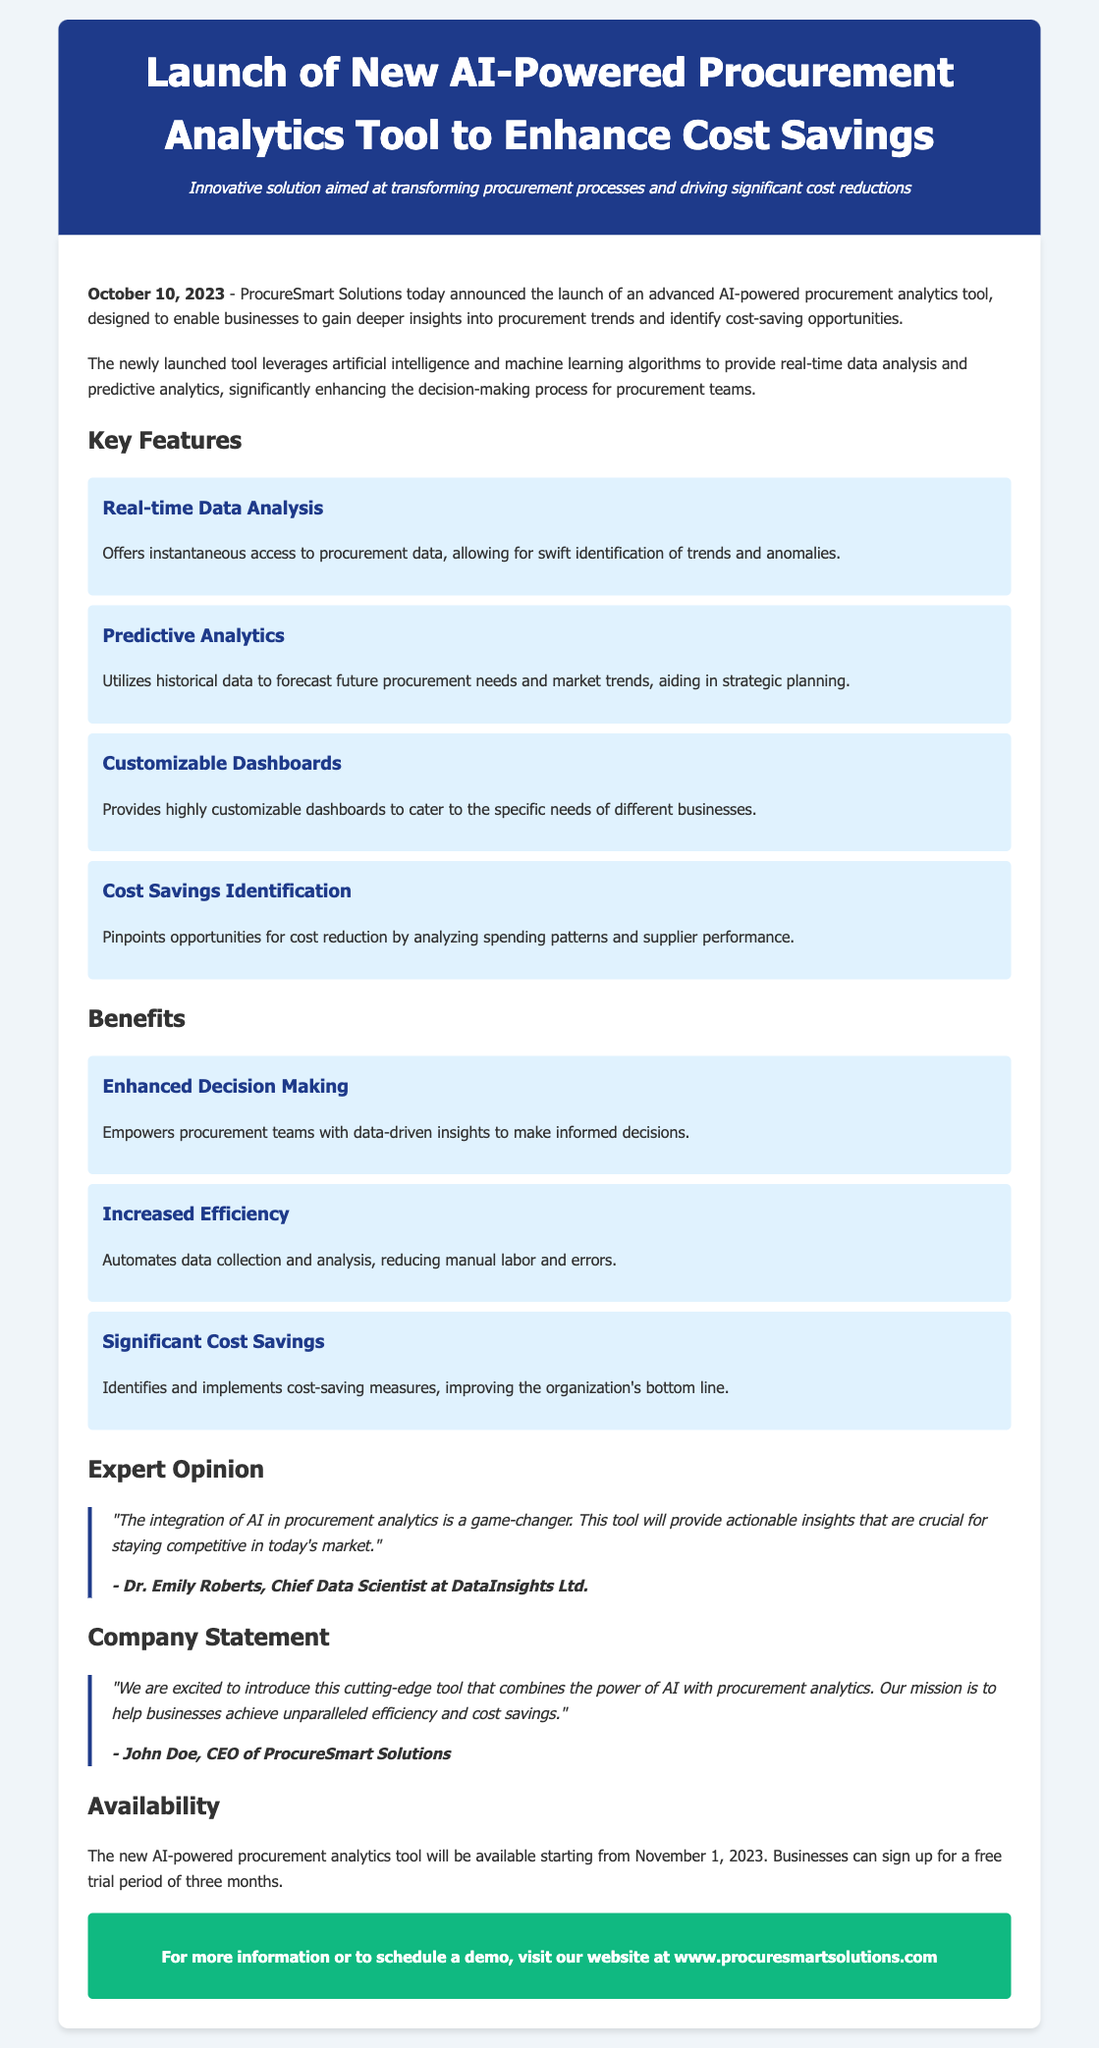What is the launch date of the new tool? The launch date mentioned in the document is October 10, 2023.
Answer: October 10, 2023 What is the name of the CEO of ProcureSmart Solutions? The CEO's name provided in the document is John Doe.
Answer: John Doe What will be the availability date of the tool? The document states that the tool will be available starting from November 1, 2023.
Answer: November 1, 2023 What type of analytics does the tool provide? The document mentions that the tool provides predictive analytics.
Answer: Predictive analytics What is one of the key features of the tool? The document lists several features; one of them is real-time data analysis.
Answer: Real-time data analysis How many months is the free trial period? According to the document, the free trial period lasts for three months.
Answer: Three months What benefit does the tool aim to provide regarding cost? The document states that the tool aims to provide significant cost savings.
Answer: Significant cost savings Who is the Chief Data Scientist quoted in the document? The document includes a quote from Dr. Emily Roberts.
Answer: Dr. Emily Roberts What is the tone of the company statement in the document? The company statement describes the tool as cutting-edge, indicating a positive tone.
Answer: Cutting-edge 